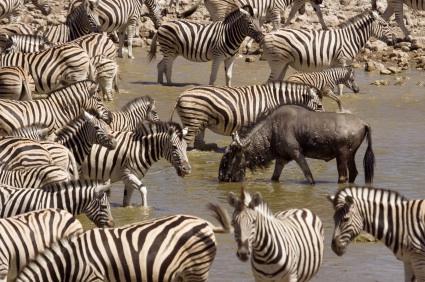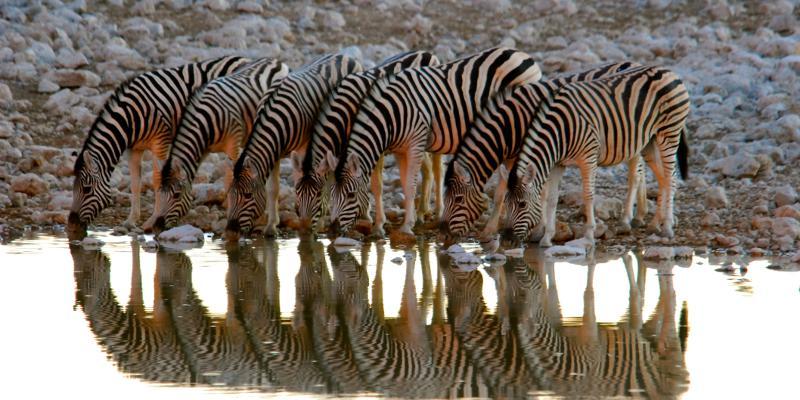The first image is the image on the left, the second image is the image on the right. For the images shown, is this caption "In the right image, there are zebras drinking from water." true? Answer yes or no. Yes. 